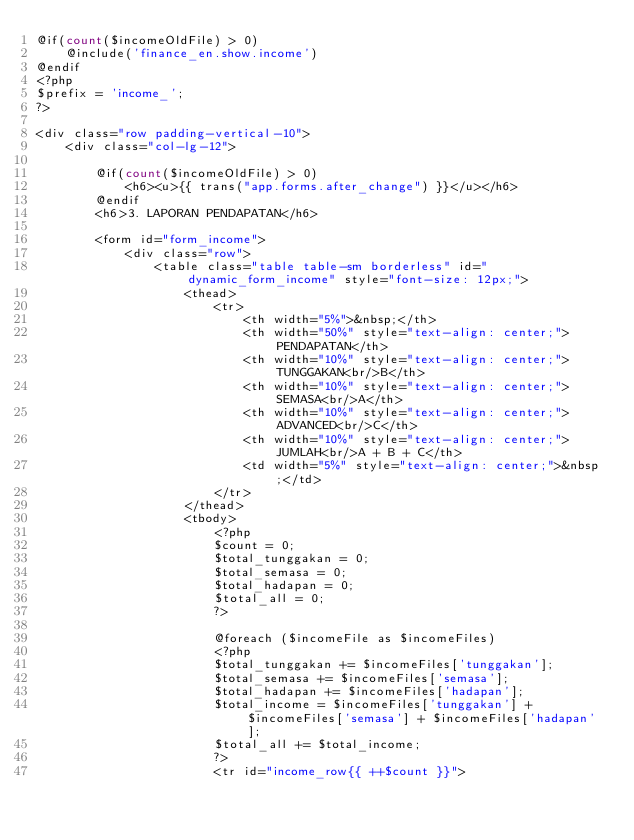<code> <loc_0><loc_0><loc_500><loc_500><_PHP_>@if(count($incomeOldFile) > 0)
    @include('finance_en.show.income')
@endif
<?php
$prefix = 'income_';
?>

<div class="row padding-vertical-10">
    <div class="col-lg-12">

        @if(count($incomeOldFile) > 0)
            <h6><u>{{ trans("app.forms.after_change") }}</u></h6>
        @endif
        <h6>3. LAPORAN PENDAPATAN</h6>

        <form id="form_income">
            <div class="row">
                <table class="table table-sm borderless" id="dynamic_form_income" style="font-size: 12px;">
                    <thead>
                        <tr>
                            <th width="5%">&nbsp;</th>
                            <th width="50%" style="text-align: center;">PENDAPATAN</th>
                            <th width="10%" style="text-align: center;">TUNGGAKAN<br/>B</th>
                            <th width="10%" style="text-align: center;">SEMASA<br/>A</th>
                            <th width="10%" style="text-align: center;">ADVANCED<br/>C</th>
                            <th width="10%" style="text-align: center;">JUMLAH<br/>A + B + C</th>
                            <td width="5%" style="text-align: center;">&nbsp;</td>
                        </tr>
                    </thead>
                    <tbody>
                        <?php
                        $count = 0;
                        $total_tunggakan = 0;
                        $total_semasa = 0;
                        $total_hadapan = 0;
                        $total_all = 0;
                        ?>

                        @foreach ($incomeFile as $incomeFiles)
                        <?php
                        $total_tunggakan += $incomeFiles['tunggakan'];
                        $total_semasa += $incomeFiles['semasa'];
                        $total_hadapan += $incomeFiles['hadapan'];
                        $total_income = $incomeFiles['tunggakan'] + $incomeFiles['semasa'] + $incomeFiles['hadapan'];
                        $total_all += $total_income;
                        ?>
                        <tr id="income_row{{ ++$count }}"></code> 